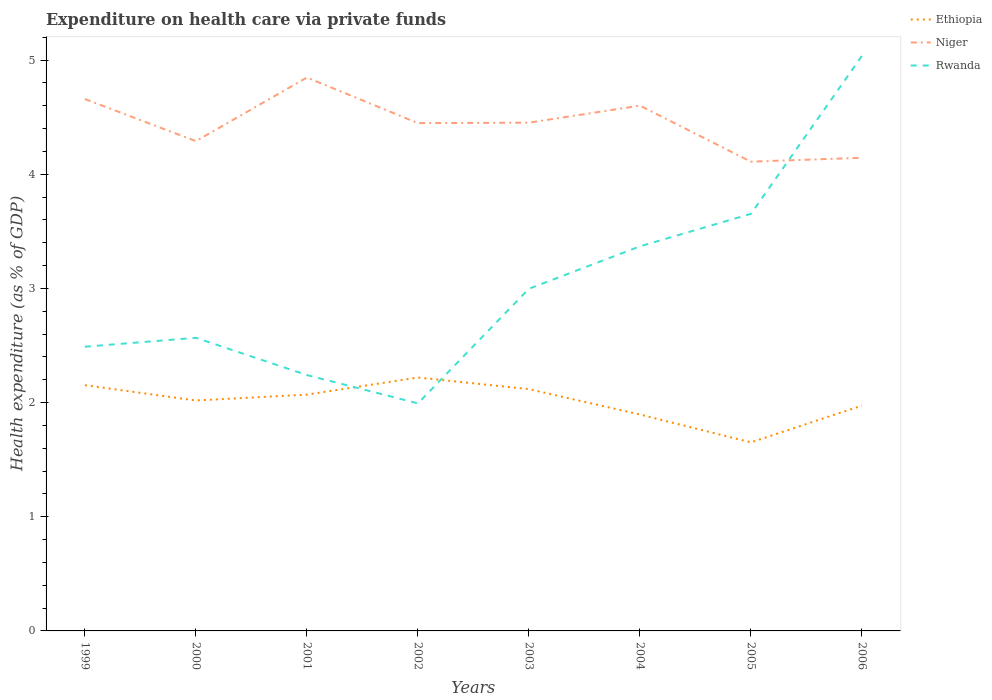Does the line corresponding to Rwanda intersect with the line corresponding to Niger?
Keep it short and to the point. Yes. Is the number of lines equal to the number of legend labels?
Your answer should be very brief. Yes. Across all years, what is the maximum expenditure made on health care in Ethiopia?
Make the answer very short. 1.65. In which year was the expenditure made on health care in Rwanda maximum?
Provide a short and direct response. 2002. What is the total expenditure made on health care in Niger in the graph?
Keep it short and to the point. 0.34. What is the difference between the highest and the second highest expenditure made on health care in Niger?
Your response must be concise. 0.74. What is the difference between the highest and the lowest expenditure made on health care in Ethiopia?
Provide a succinct answer. 5. Is the expenditure made on health care in Niger strictly greater than the expenditure made on health care in Rwanda over the years?
Keep it short and to the point. No. How many lines are there?
Keep it short and to the point. 3. What is the difference between two consecutive major ticks on the Y-axis?
Keep it short and to the point. 1. How many legend labels are there?
Offer a terse response. 3. How are the legend labels stacked?
Your answer should be compact. Vertical. What is the title of the graph?
Provide a succinct answer. Expenditure on health care via private funds. Does "Chile" appear as one of the legend labels in the graph?
Give a very brief answer. No. What is the label or title of the X-axis?
Keep it short and to the point. Years. What is the label or title of the Y-axis?
Provide a short and direct response. Health expenditure (as % of GDP). What is the Health expenditure (as % of GDP) in Ethiopia in 1999?
Make the answer very short. 2.15. What is the Health expenditure (as % of GDP) of Niger in 1999?
Give a very brief answer. 4.66. What is the Health expenditure (as % of GDP) in Rwanda in 1999?
Offer a terse response. 2.49. What is the Health expenditure (as % of GDP) of Ethiopia in 2000?
Your answer should be very brief. 2.02. What is the Health expenditure (as % of GDP) in Niger in 2000?
Provide a succinct answer. 4.29. What is the Health expenditure (as % of GDP) in Rwanda in 2000?
Give a very brief answer. 2.57. What is the Health expenditure (as % of GDP) in Ethiopia in 2001?
Give a very brief answer. 2.07. What is the Health expenditure (as % of GDP) of Niger in 2001?
Offer a very short reply. 4.85. What is the Health expenditure (as % of GDP) in Rwanda in 2001?
Offer a very short reply. 2.24. What is the Health expenditure (as % of GDP) in Ethiopia in 2002?
Ensure brevity in your answer.  2.22. What is the Health expenditure (as % of GDP) in Niger in 2002?
Make the answer very short. 4.45. What is the Health expenditure (as % of GDP) of Rwanda in 2002?
Offer a very short reply. 1.99. What is the Health expenditure (as % of GDP) of Ethiopia in 2003?
Ensure brevity in your answer.  2.12. What is the Health expenditure (as % of GDP) in Niger in 2003?
Offer a terse response. 4.45. What is the Health expenditure (as % of GDP) of Rwanda in 2003?
Provide a short and direct response. 3. What is the Health expenditure (as % of GDP) of Ethiopia in 2004?
Give a very brief answer. 1.9. What is the Health expenditure (as % of GDP) in Niger in 2004?
Keep it short and to the point. 4.6. What is the Health expenditure (as % of GDP) of Rwanda in 2004?
Give a very brief answer. 3.37. What is the Health expenditure (as % of GDP) of Ethiopia in 2005?
Give a very brief answer. 1.65. What is the Health expenditure (as % of GDP) of Niger in 2005?
Offer a terse response. 4.11. What is the Health expenditure (as % of GDP) in Rwanda in 2005?
Provide a short and direct response. 3.65. What is the Health expenditure (as % of GDP) in Ethiopia in 2006?
Your response must be concise. 1.97. What is the Health expenditure (as % of GDP) of Niger in 2006?
Your response must be concise. 4.14. What is the Health expenditure (as % of GDP) of Rwanda in 2006?
Provide a short and direct response. 5.04. Across all years, what is the maximum Health expenditure (as % of GDP) of Ethiopia?
Offer a terse response. 2.22. Across all years, what is the maximum Health expenditure (as % of GDP) in Niger?
Ensure brevity in your answer.  4.85. Across all years, what is the maximum Health expenditure (as % of GDP) of Rwanda?
Offer a terse response. 5.04. Across all years, what is the minimum Health expenditure (as % of GDP) of Ethiopia?
Make the answer very short. 1.65. Across all years, what is the minimum Health expenditure (as % of GDP) in Niger?
Provide a succinct answer. 4.11. Across all years, what is the minimum Health expenditure (as % of GDP) in Rwanda?
Your answer should be very brief. 1.99. What is the total Health expenditure (as % of GDP) in Ethiopia in the graph?
Provide a succinct answer. 16.1. What is the total Health expenditure (as % of GDP) of Niger in the graph?
Offer a terse response. 35.55. What is the total Health expenditure (as % of GDP) in Rwanda in the graph?
Offer a terse response. 24.35. What is the difference between the Health expenditure (as % of GDP) of Ethiopia in 1999 and that in 2000?
Give a very brief answer. 0.13. What is the difference between the Health expenditure (as % of GDP) in Niger in 1999 and that in 2000?
Ensure brevity in your answer.  0.37. What is the difference between the Health expenditure (as % of GDP) in Rwanda in 1999 and that in 2000?
Ensure brevity in your answer.  -0.08. What is the difference between the Health expenditure (as % of GDP) of Ethiopia in 1999 and that in 2001?
Provide a succinct answer. 0.08. What is the difference between the Health expenditure (as % of GDP) of Niger in 1999 and that in 2001?
Your answer should be very brief. -0.19. What is the difference between the Health expenditure (as % of GDP) in Rwanda in 1999 and that in 2001?
Ensure brevity in your answer.  0.25. What is the difference between the Health expenditure (as % of GDP) in Ethiopia in 1999 and that in 2002?
Ensure brevity in your answer.  -0.07. What is the difference between the Health expenditure (as % of GDP) in Niger in 1999 and that in 2002?
Ensure brevity in your answer.  0.21. What is the difference between the Health expenditure (as % of GDP) of Rwanda in 1999 and that in 2002?
Offer a very short reply. 0.5. What is the difference between the Health expenditure (as % of GDP) in Ethiopia in 1999 and that in 2003?
Your response must be concise. 0.03. What is the difference between the Health expenditure (as % of GDP) of Niger in 1999 and that in 2003?
Ensure brevity in your answer.  0.21. What is the difference between the Health expenditure (as % of GDP) in Rwanda in 1999 and that in 2003?
Your response must be concise. -0.51. What is the difference between the Health expenditure (as % of GDP) in Ethiopia in 1999 and that in 2004?
Give a very brief answer. 0.26. What is the difference between the Health expenditure (as % of GDP) of Niger in 1999 and that in 2004?
Offer a terse response. 0.06. What is the difference between the Health expenditure (as % of GDP) in Rwanda in 1999 and that in 2004?
Ensure brevity in your answer.  -0.88. What is the difference between the Health expenditure (as % of GDP) in Ethiopia in 1999 and that in 2005?
Provide a succinct answer. 0.5. What is the difference between the Health expenditure (as % of GDP) of Niger in 1999 and that in 2005?
Ensure brevity in your answer.  0.55. What is the difference between the Health expenditure (as % of GDP) of Rwanda in 1999 and that in 2005?
Your answer should be compact. -1.16. What is the difference between the Health expenditure (as % of GDP) in Ethiopia in 1999 and that in 2006?
Give a very brief answer. 0.18. What is the difference between the Health expenditure (as % of GDP) of Niger in 1999 and that in 2006?
Your response must be concise. 0.51. What is the difference between the Health expenditure (as % of GDP) in Rwanda in 1999 and that in 2006?
Make the answer very short. -2.55. What is the difference between the Health expenditure (as % of GDP) of Ethiopia in 2000 and that in 2001?
Offer a terse response. -0.05. What is the difference between the Health expenditure (as % of GDP) of Niger in 2000 and that in 2001?
Your answer should be compact. -0.56. What is the difference between the Health expenditure (as % of GDP) of Rwanda in 2000 and that in 2001?
Keep it short and to the point. 0.33. What is the difference between the Health expenditure (as % of GDP) in Ethiopia in 2000 and that in 2002?
Your response must be concise. -0.2. What is the difference between the Health expenditure (as % of GDP) of Niger in 2000 and that in 2002?
Provide a short and direct response. -0.16. What is the difference between the Health expenditure (as % of GDP) in Rwanda in 2000 and that in 2002?
Keep it short and to the point. 0.57. What is the difference between the Health expenditure (as % of GDP) of Ethiopia in 2000 and that in 2003?
Your response must be concise. -0.1. What is the difference between the Health expenditure (as % of GDP) of Niger in 2000 and that in 2003?
Make the answer very short. -0.16. What is the difference between the Health expenditure (as % of GDP) in Rwanda in 2000 and that in 2003?
Your response must be concise. -0.43. What is the difference between the Health expenditure (as % of GDP) in Ethiopia in 2000 and that in 2004?
Your answer should be compact. 0.12. What is the difference between the Health expenditure (as % of GDP) of Niger in 2000 and that in 2004?
Provide a succinct answer. -0.31. What is the difference between the Health expenditure (as % of GDP) of Rwanda in 2000 and that in 2004?
Your answer should be compact. -0.8. What is the difference between the Health expenditure (as % of GDP) of Ethiopia in 2000 and that in 2005?
Keep it short and to the point. 0.37. What is the difference between the Health expenditure (as % of GDP) in Niger in 2000 and that in 2005?
Offer a terse response. 0.18. What is the difference between the Health expenditure (as % of GDP) of Rwanda in 2000 and that in 2005?
Give a very brief answer. -1.09. What is the difference between the Health expenditure (as % of GDP) of Ethiopia in 2000 and that in 2006?
Your answer should be very brief. 0.04. What is the difference between the Health expenditure (as % of GDP) of Niger in 2000 and that in 2006?
Your answer should be compact. 0.15. What is the difference between the Health expenditure (as % of GDP) in Rwanda in 2000 and that in 2006?
Offer a very short reply. -2.47. What is the difference between the Health expenditure (as % of GDP) of Ethiopia in 2001 and that in 2002?
Provide a short and direct response. -0.15. What is the difference between the Health expenditure (as % of GDP) in Niger in 2001 and that in 2002?
Offer a terse response. 0.4. What is the difference between the Health expenditure (as % of GDP) in Rwanda in 2001 and that in 2002?
Your answer should be very brief. 0.25. What is the difference between the Health expenditure (as % of GDP) in Ethiopia in 2001 and that in 2003?
Keep it short and to the point. -0.05. What is the difference between the Health expenditure (as % of GDP) in Niger in 2001 and that in 2003?
Ensure brevity in your answer.  0.4. What is the difference between the Health expenditure (as % of GDP) of Rwanda in 2001 and that in 2003?
Offer a very short reply. -0.76. What is the difference between the Health expenditure (as % of GDP) in Ethiopia in 2001 and that in 2004?
Your answer should be very brief. 0.17. What is the difference between the Health expenditure (as % of GDP) of Niger in 2001 and that in 2004?
Your answer should be compact. 0.25. What is the difference between the Health expenditure (as % of GDP) in Rwanda in 2001 and that in 2004?
Offer a terse response. -1.13. What is the difference between the Health expenditure (as % of GDP) of Ethiopia in 2001 and that in 2005?
Your response must be concise. 0.42. What is the difference between the Health expenditure (as % of GDP) in Niger in 2001 and that in 2005?
Give a very brief answer. 0.74. What is the difference between the Health expenditure (as % of GDP) of Rwanda in 2001 and that in 2005?
Your answer should be very brief. -1.41. What is the difference between the Health expenditure (as % of GDP) in Ethiopia in 2001 and that in 2006?
Make the answer very short. 0.1. What is the difference between the Health expenditure (as % of GDP) of Niger in 2001 and that in 2006?
Ensure brevity in your answer.  0.7. What is the difference between the Health expenditure (as % of GDP) of Rwanda in 2001 and that in 2006?
Your response must be concise. -2.8. What is the difference between the Health expenditure (as % of GDP) in Ethiopia in 2002 and that in 2003?
Provide a succinct answer. 0.1. What is the difference between the Health expenditure (as % of GDP) of Niger in 2002 and that in 2003?
Your response must be concise. -0. What is the difference between the Health expenditure (as % of GDP) in Rwanda in 2002 and that in 2003?
Your answer should be compact. -1. What is the difference between the Health expenditure (as % of GDP) in Ethiopia in 2002 and that in 2004?
Your answer should be compact. 0.32. What is the difference between the Health expenditure (as % of GDP) of Niger in 2002 and that in 2004?
Ensure brevity in your answer.  -0.15. What is the difference between the Health expenditure (as % of GDP) of Rwanda in 2002 and that in 2004?
Give a very brief answer. -1.38. What is the difference between the Health expenditure (as % of GDP) in Ethiopia in 2002 and that in 2005?
Keep it short and to the point. 0.57. What is the difference between the Health expenditure (as % of GDP) in Niger in 2002 and that in 2005?
Ensure brevity in your answer.  0.34. What is the difference between the Health expenditure (as % of GDP) in Rwanda in 2002 and that in 2005?
Your answer should be very brief. -1.66. What is the difference between the Health expenditure (as % of GDP) of Ethiopia in 2002 and that in 2006?
Offer a terse response. 0.25. What is the difference between the Health expenditure (as % of GDP) of Niger in 2002 and that in 2006?
Ensure brevity in your answer.  0.3. What is the difference between the Health expenditure (as % of GDP) in Rwanda in 2002 and that in 2006?
Provide a succinct answer. -3.04. What is the difference between the Health expenditure (as % of GDP) in Ethiopia in 2003 and that in 2004?
Your answer should be compact. 0.22. What is the difference between the Health expenditure (as % of GDP) in Niger in 2003 and that in 2004?
Give a very brief answer. -0.15. What is the difference between the Health expenditure (as % of GDP) of Rwanda in 2003 and that in 2004?
Provide a short and direct response. -0.37. What is the difference between the Health expenditure (as % of GDP) in Ethiopia in 2003 and that in 2005?
Your answer should be compact. 0.47. What is the difference between the Health expenditure (as % of GDP) in Niger in 2003 and that in 2005?
Offer a very short reply. 0.34. What is the difference between the Health expenditure (as % of GDP) of Rwanda in 2003 and that in 2005?
Offer a terse response. -0.66. What is the difference between the Health expenditure (as % of GDP) in Ethiopia in 2003 and that in 2006?
Make the answer very short. 0.14. What is the difference between the Health expenditure (as % of GDP) in Niger in 2003 and that in 2006?
Your answer should be compact. 0.31. What is the difference between the Health expenditure (as % of GDP) in Rwanda in 2003 and that in 2006?
Keep it short and to the point. -2.04. What is the difference between the Health expenditure (as % of GDP) of Ethiopia in 2004 and that in 2005?
Provide a succinct answer. 0.24. What is the difference between the Health expenditure (as % of GDP) of Niger in 2004 and that in 2005?
Your response must be concise. 0.49. What is the difference between the Health expenditure (as % of GDP) of Rwanda in 2004 and that in 2005?
Give a very brief answer. -0.28. What is the difference between the Health expenditure (as % of GDP) in Ethiopia in 2004 and that in 2006?
Offer a terse response. -0.08. What is the difference between the Health expenditure (as % of GDP) of Niger in 2004 and that in 2006?
Ensure brevity in your answer.  0.46. What is the difference between the Health expenditure (as % of GDP) of Rwanda in 2004 and that in 2006?
Offer a terse response. -1.67. What is the difference between the Health expenditure (as % of GDP) of Ethiopia in 2005 and that in 2006?
Offer a very short reply. -0.32. What is the difference between the Health expenditure (as % of GDP) in Niger in 2005 and that in 2006?
Offer a terse response. -0.03. What is the difference between the Health expenditure (as % of GDP) of Rwanda in 2005 and that in 2006?
Give a very brief answer. -1.38. What is the difference between the Health expenditure (as % of GDP) in Ethiopia in 1999 and the Health expenditure (as % of GDP) in Niger in 2000?
Make the answer very short. -2.14. What is the difference between the Health expenditure (as % of GDP) in Ethiopia in 1999 and the Health expenditure (as % of GDP) in Rwanda in 2000?
Make the answer very short. -0.41. What is the difference between the Health expenditure (as % of GDP) in Niger in 1999 and the Health expenditure (as % of GDP) in Rwanda in 2000?
Offer a terse response. 2.09. What is the difference between the Health expenditure (as % of GDP) in Ethiopia in 1999 and the Health expenditure (as % of GDP) in Niger in 2001?
Give a very brief answer. -2.69. What is the difference between the Health expenditure (as % of GDP) of Ethiopia in 1999 and the Health expenditure (as % of GDP) of Rwanda in 2001?
Keep it short and to the point. -0.09. What is the difference between the Health expenditure (as % of GDP) of Niger in 1999 and the Health expenditure (as % of GDP) of Rwanda in 2001?
Give a very brief answer. 2.42. What is the difference between the Health expenditure (as % of GDP) of Ethiopia in 1999 and the Health expenditure (as % of GDP) of Niger in 2002?
Your response must be concise. -2.3. What is the difference between the Health expenditure (as % of GDP) of Ethiopia in 1999 and the Health expenditure (as % of GDP) of Rwanda in 2002?
Provide a succinct answer. 0.16. What is the difference between the Health expenditure (as % of GDP) of Niger in 1999 and the Health expenditure (as % of GDP) of Rwanda in 2002?
Offer a very short reply. 2.67. What is the difference between the Health expenditure (as % of GDP) in Ethiopia in 1999 and the Health expenditure (as % of GDP) in Niger in 2003?
Provide a succinct answer. -2.3. What is the difference between the Health expenditure (as % of GDP) of Ethiopia in 1999 and the Health expenditure (as % of GDP) of Rwanda in 2003?
Provide a short and direct response. -0.84. What is the difference between the Health expenditure (as % of GDP) of Niger in 1999 and the Health expenditure (as % of GDP) of Rwanda in 2003?
Your response must be concise. 1.66. What is the difference between the Health expenditure (as % of GDP) of Ethiopia in 1999 and the Health expenditure (as % of GDP) of Niger in 2004?
Your answer should be very brief. -2.45. What is the difference between the Health expenditure (as % of GDP) of Ethiopia in 1999 and the Health expenditure (as % of GDP) of Rwanda in 2004?
Your answer should be very brief. -1.22. What is the difference between the Health expenditure (as % of GDP) of Niger in 1999 and the Health expenditure (as % of GDP) of Rwanda in 2004?
Offer a very short reply. 1.29. What is the difference between the Health expenditure (as % of GDP) in Ethiopia in 1999 and the Health expenditure (as % of GDP) in Niger in 2005?
Offer a very short reply. -1.96. What is the difference between the Health expenditure (as % of GDP) in Ethiopia in 1999 and the Health expenditure (as % of GDP) in Rwanda in 2005?
Offer a terse response. -1.5. What is the difference between the Health expenditure (as % of GDP) in Niger in 1999 and the Health expenditure (as % of GDP) in Rwanda in 2005?
Your answer should be very brief. 1.01. What is the difference between the Health expenditure (as % of GDP) of Ethiopia in 1999 and the Health expenditure (as % of GDP) of Niger in 2006?
Provide a succinct answer. -1.99. What is the difference between the Health expenditure (as % of GDP) of Ethiopia in 1999 and the Health expenditure (as % of GDP) of Rwanda in 2006?
Keep it short and to the point. -2.88. What is the difference between the Health expenditure (as % of GDP) of Niger in 1999 and the Health expenditure (as % of GDP) of Rwanda in 2006?
Offer a very short reply. -0.38. What is the difference between the Health expenditure (as % of GDP) in Ethiopia in 2000 and the Health expenditure (as % of GDP) in Niger in 2001?
Give a very brief answer. -2.83. What is the difference between the Health expenditure (as % of GDP) in Ethiopia in 2000 and the Health expenditure (as % of GDP) in Rwanda in 2001?
Provide a short and direct response. -0.22. What is the difference between the Health expenditure (as % of GDP) of Niger in 2000 and the Health expenditure (as % of GDP) of Rwanda in 2001?
Keep it short and to the point. 2.05. What is the difference between the Health expenditure (as % of GDP) in Ethiopia in 2000 and the Health expenditure (as % of GDP) in Niger in 2002?
Offer a very short reply. -2.43. What is the difference between the Health expenditure (as % of GDP) in Ethiopia in 2000 and the Health expenditure (as % of GDP) in Rwanda in 2002?
Make the answer very short. 0.03. What is the difference between the Health expenditure (as % of GDP) of Niger in 2000 and the Health expenditure (as % of GDP) of Rwanda in 2002?
Your response must be concise. 2.3. What is the difference between the Health expenditure (as % of GDP) in Ethiopia in 2000 and the Health expenditure (as % of GDP) in Niger in 2003?
Give a very brief answer. -2.43. What is the difference between the Health expenditure (as % of GDP) of Ethiopia in 2000 and the Health expenditure (as % of GDP) of Rwanda in 2003?
Ensure brevity in your answer.  -0.98. What is the difference between the Health expenditure (as % of GDP) in Niger in 2000 and the Health expenditure (as % of GDP) in Rwanda in 2003?
Your response must be concise. 1.29. What is the difference between the Health expenditure (as % of GDP) of Ethiopia in 2000 and the Health expenditure (as % of GDP) of Niger in 2004?
Offer a very short reply. -2.58. What is the difference between the Health expenditure (as % of GDP) in Ethiopia in 2000 and the Health expenditure (as % of GDP) in Rwanda in 2004?
Provide a short and direct response. -1.35. What is the difference between the Health expenditure (as % of GDP) of Niger in 2000 and the Health expenditure (as % of GDP) of Rwanda in 2004?
Your answer should be very brief. 0.92. What is the difference between the Health expenditure (as % of GDP) of Ethiopia in 2000 and the Health expenditure (as % of GDP) of Niger in 2005?
Provide a succinct answer. -2.09. What is the difference between the Health expenditure (as % of GDP) in Ethiopia in 2000 and the Health expenditure (as % of GDP) in Rwanda in 2005?
Your answer should be compact. -1.63. What is the difference between the Health expenditure (as % of GDP) in Niger in 2000 and the Health expenditure (as % of GDP) in Rwanda in 2005?
Provide a succinct answer. 0.64. What is the difference between the Health expenditure (as % of GDP) of Ethiopia in 2000 and the Health expenditure (as % of GDP) of Niger in 2006?
Offer a terse response. -2.13. What is the difference between the Health expenditure (as % of GDP) in Ethiopia in 2000 and the Health expenditure (as % of GDP) in Rwanda in 2006?
Provide a short and direct response. -3.02. What is the difference between the Health expenditure (as % of GDP) in Niger in 2000 and the Health expenditure (as % of GDP) in Rwanda in 2006?
Offer a very short reply. -0.75. What is the difference between the Health expenditure (as % of GDP) in Ethiopia in 2001 and the Health expenditure (as % of GDP) in Niger in 2002?
Offer a terse response. -2.38. What is the difference between the Health expenditure (as % of GDP) of Ethiopia in 2001 and the Health expenditure (as % of GDP) of Rwanda in 2002?
Keep it short and to the point. 0.08. What is the difference between the Health expenditure (as % of GDP) in Niger in 2001 and the Health expenditure (as % of GDP) in Rwanda in 2002?
Your answer should be very brief. 2.85. What is the difference between the Health expenditure (as % of GDP) in Ethiopia in 2001 and the Health expenditure (as % of GDP) in Niger in 2003?
Provide a succinct answer. -2.38. What is the difference between the Health expenditure (as % of GDP) in Ethiopia in 2001 and the Health expenditure (as % of GDP) in Rwanda in 2003?
Your response must be concise. -0.93. What is the difference between the Health expenditure (as % of GDP) in Niger in 2001 and the Health expenditure (as % of GDP) in Rwanda in 2003?
Ensure brevity in your answer.  1.85. What is the difference between the Health expenditure (as % of GDP) in Ethiopia in 2001 and the Health expenditure (as % of GDP) in Niger in 2004?
Give a very brief answer. -2.53. What is the difference between the Health expenditure (as % of GDP) in Ethiopia in 2001 and the Health expenditure (as % of GDP) in Rwanda in 2004?
Provide a short and direct response. -1.3. What is the difference between the Health expenditure (as % of GDP) of Niger in 2001 and the Health expenditure (as % of GDP) of Rwanda in 2004?
Your answer should be very brief. 1.48. What is the difference between the Health expenditure (as % of GDP) of Ethiopia in 2001 and the Health expenditure (as % of GDP) of Niger in 2005?
Your answer should be very brief. -2.04. What is the difference between the Health expenditure (as % of GDP) of Ethiopia in 2001 and the Health expenditure (as % of GDP) of Rwanda in 2005?
Give a very brief answer. -1.58. What is the difference between the Health expenditure (as % of GDP) of Niger in 2001 and the Health expenditure (as % of GDP) of Rwanda in 2005?
Give a very brief answer. 1.19. What is the difference between the Health expenditure (as % of GDP) in Ethiopia in 2001 and the Health expenditure (as % of GDP) in Niger in 2006?
Provide a succinct answer. -2.07. What is the difference between the Health expenditure (as % of GDP) of Ethiopia in 2001 and the Health expenditure (as % of GDP) of Rwanda in 2006?
Offer a very short reply. -2.97. What is the difference between the Health expenditure (as % of GDP) of Niger in 2001 and the Health expenditure (as % of GDP) of Rwanda in 2006?
Offer a terse response. -0.19. What is the difference between the Health expenditure (as % of GDP) of Ethiopia in 2002 and the Health expenditure (as % of GDP) of Niger in 2003?
Keep it short and to the point. -2.23. What is the difference between the Health expenditure (as % of GDP) in Ethiopia in 2002 and the Health expenditure (as % of GDP) in Rwanda in 2003?
Your answer should be compact. -0.78. What is the difference between the Health expenditure (as % of GDP) of Niger in 2002 and the Health expenditure (as % of GDP) of Rwanda in 2003?
Offer a terse response. 1.45. What is the difference between the Health expenditure (as % of GDP) of Ethiopia in 2002 and the Health expenditure (as % of GDP) of Niger in 2004?
Ensure brevity in your answer.  -2.38. What is the difference between the Health expenditure (as % of GDP) in Ethiopia in 2002 and the Health expenditure (as % of GDP) in Rwanda in 2004?
Offer a very short reply. -1.15. What is the difference between the Health expenditure (as % of GDP) in Niger in 2002 and the Health expenditure (as % of GDP) in Rwanda in 2004?
Provide a succinct answer. 1.08. What is the difference between the Health expenditure (as % of GDP) in Ethiopia in 2002 and the Health expenditure (as % of GDP) in Niger in 2005?
Your answer should be very brief. -1.89. What is the difference between the Health expenditure (as % of GDP) in Ethiopia in 2002 and the Health expenditure (as % of GDP) in Rwanda in 2005?
Offer a very short reply. -1.43. What is the difference between the Health expenditure (as % of GDP) in Niger in 2002 and the Health expenditure (as % of GDP) in Rwanda in 2005?
Your answer should be compact. 0.79. What is the difference between the Health expenditure (as % of GDP) in Ethiopia in 2002 and the Health expenditure (as % of GDP) in Niger in 2006?
Offer a very short reply. -1.92. What is the difference between the Health expenditure (as % of GDP) in Ethiopia in 2002 and the Health expenditure (as % of GDP) in Rwanda in 2006?
Your answer should be very brief. -2.82. What is the difference between the Health expenditure (as % of GDP) of Niger in 2002 and the Health expenditure (as % of GDP) of Rwanda in 2006?
Your answer should be compact. -0.59. What is the difference between the Health expenditure (as % of GDP) of Ethiopia in 2003 and the Health expenditure (as % of GDP) of Niger in 2004?
Your answer should be compact. -2.48. What is the difference between the Health expenditure (as % of GDP) in Ethiopia in 2003 and the Health expenditure (as % of GDP) in Rwanda in 2004?
Provide a short and direct response. -1.25. What is the difference between the Health expenditure (as % of GDP) in Niger in 2003 and the Health expenditure (as % of GDP) in Rwanda in 2004?
Offer a terse response. 1.08. What is the difference between the Health expenditure (as % of GDP) in Ethiopia in 2003 and the Health expenditure (as % of GDP) in Niger in 2005?
Provide a succinct answer. -1.99. What is the difference between the Health expenditure (as % of GDP) in Ethiopia in 2003 and the Health expenditure (as % of GDP) in Rwanda in 2005?
Make the answer very short. -1.54. What is the difference between the Health expenditure (as % of GDP) in Niger in 2003 and the Health expenditure (as % of GDP) in Rwanda in 2005?
Offer a terse response. 0.8. What is the difference between the Health expenditure (as % of GDP) in Ethiopia in 2003 and the Health expenditure (as % of GDP) in Niger in 2006?
Ensure brevity in your answer.  -2.03. What is the difference between the Health expenditure (as % of GDP) of Ethiopia in 2003 and the Health expenditure (as % of GDP) of Rwanda in 2006?
Your response must be concise. -2.92. What is the difference between the Health expenditure (as % of GDP) of Niger in 2003 and the Health expenditure (as % of GDP) of Rwanda in 2006?
Your answer should be very brief. -0.58. What is the difference between the Health expenditure (as % of GDP) of Ethiopia in 2004 and the Health expenditure (as % of GDP) of Niger in 2005?
Your response must be concise. -2.21. What is the difference between the Health expenditure (as % of GDP) in Ethiopia in 2004 and the Health expenditure (as % of GDP) in Rwanda in 2005?
Ensure brevity in your answer.  -1.76. What is the difference between the Health expenditure (as % of GDP) in Niger in 2004 and the Health expenditure (as % of GDP) in Rwanda in 2005?
Provide a short and direct response. 0.95. What is the difference between the Health expenditure (as % of GDP) in Ethiopia in 2004 and the Health expenditure (as % of GDP) in Niger in 2006?
Keep it short and to the point. -2.25. What is the difference between the Health expenditure (as % of GDP) of Ethiopia in 2004 and the Health expenditure (as % of GDP) of Rwanda in 2006?
Your answer should be compact. -3.14. What is the difference between the Health expenditure (as % of GDP) of Niger in 2004 and the Health expenditure (as % of GDP) of Rwanda in 2006?
Provide a succinct answer. -0.44. What is the difference between the Health expenditure (as % of GDP) of Ethiopia in 2005 and the Health expenditure (as % of GDP) of Niger in 2006?
Offer a terse response. -2.49. What is the difference between the Health expenditure (as % of GDP) of Ethiopia in 2005 and the Health expenditure (as % of GDP) of Rwanda in 2006?
Provide a succinct answer. -3.39. What is the difference between the Health expenditure (as % of GDP) in Niger in 2005 and the Health expenditure (as % of GDP) in Rwanda in 2006?
Your answer should be very brief. -0.93. What is the average Health expenditure (as % of GDP) of Ethiopia per year?
Provide a succinct answer. 2.01. What is the average Health expenditure (as % of GDP) in Niger per year?
Your answer should be compact. 4.44. What is the average Health expenditure (as % of GDP) of Rwanda per year?
Offer a terse response. 3.04. In the year 1999, what is the difference between the Health expenditure (as % of GDP) of Ethiopia and Health expenditure (as % of GDP) of Niger?
Your answer should be very brief. -2.51. In the year 1999, what is the difference between the Health expenditure (as % of GDP) of Ethiopia and Health expenditure (as % of GDP) of Rwanda?
Your answer should be compact. -0.34. In the year 1999, what is the difference between the Health expenditure (as % of GDP) of Niger and Health expenditure (as % of GDP) of Rwanda?
Your answer should be compact. 2.17. In the year 2000, what is the difference between the Health expenditure (as % of GDP) of Ethiopia and Health expenditure (as % of GDP) of Niger?
Provide a succinct answer. -2.27. In the year 2000, what is the difference between the Health expenditure (as % of GDP) in Ethiopia and Health expenditure (as % of GDP) in Rwanda?
Your answer should be very brief. -0.55. In the year 2000, what is the difference between the Health expenditure (as % of GDP) of Niger and Health expenditure (as % of GDP) of Rwanda?
Provide a short and direct response. 1.72. In the year 2001, what is the difference between the Health expenditure (as % of GDP) in Ethiopia and Health expenditure (as % of GDP) in Niger?
Offer a terse response. -2.78. In the year 2001, what is the difference between the Health expenditure (as % of GDP) in Ethiopia and Health expenditure (as % of GDP) in Rwanda?
Ensure brevity in your answer.  -0.17. In the year 2001, what is the difference between the Health expenditure (as % of GDP) of Niger and Health expenditure (as % of GDP) of Rwanda?
Your response must be concise. 2.61. In the year 2002, what is the difference between the Health expenditure (as % of GDP) in Ethiopia and Health expenditure (as % of GDP) in Niger?
Your answer should be compact. -2.23. In the year 2002, what is the difference between the Health expenditure (as % of GDP) of Ethiopia and Health expenditure (as % of GDP) of Rwanda?
Your answer should be compact. 0.23. In the year 2002, what is the difference between the Health expenditure (as % of GDP) in Niger and Health expenditure (as % of GDP) in Rwanda?
Your answer should be very brief. 2.45. In the year 2003, what is the difference between the Health expenditure (as % of GDP) in Ethiopia and Health expenditure (as % of GDP) in Niger?
Give a very brief answer. -2.33. In the year 2003, what is the difference between the Health expenditure (as % of GDP) of Ethiopia and Health expenditure (as % of GDP) of Rwanda?
Ensure brevity in your answer.  -0.88. In the year 2003, what is the difference between the Health expenditure (as % of GDP) in Niger and Health expenditure (as % of GDP) in Rwanda?
Give a very brief answer. 1.45. In the year 2004, what is the difference between the Health expenditure (as % of GDP) in Ethiopia and Health expenditure (as % of GDP) in Niger?
Your answer should be compact. -2.71. In the year 2004, what is the difference between the Health expenditure (as % of GDP) of Ethiopia and Health expenditure (as % of GDP) of Rwanda?
Offer a very short reply. -1.47. In the year 2004, what is the difference between the Health expenditure (as % of GDP) in Niger and Health expenditure (as % of GDP) in Rwanda?
Make the answer very short. 1.23. In the year 2005, what is the difference between the Health expenditure (as % of GDP) of Ethiopia and Health expenditure (as % of GDP) of Niger?
Offer a terse response. -2.46. In the year 2005, what is the difference between the Health expenditure (as % of GDP) in Ethiopia and Health expenditure (as % of GDP) in Rwanda?
Provide a short and direct response. -2. In the year 2005, what is the difference between the Health expenditure (as % of GDP) of Niger and Health expenditure (as % of GDP) of Rwanda?
Provide a short and direct response. 0.46. In the year 2006, what is the difference between the Health expenditure (as % of GDP) of Ethiopia and Health expenditure (as % of GDP) of Niger?
Your answer should be compact. -2.17. In the year 2006, what is the difference between the Health expenditure (as % of GDP) of Ethiopia and Health expenditure (as % of GDP) of Rwanda?
Your answer should be compact. -3.06. In the year 2006, what is the difference between the Health expenditure (as % of GDP) in Niger and Health expenditure (as % of GDP) in Rwanda?
Give a very brief answer. -0.89. What is the ratio of the Health expenditure (as % of GDP) of Ethiopia in 1999 to that in 2000?
Provide a short and direct response. 1.07. What is the ratio of the Health expenditure (as % of GDP) in Niger in 1999 to that in 2000?
Your answer should be very brief. 1.09. What is the ratio of the Health expenditure (as % of GDP) of Rwanda in 1999 to that in 2000?
Provide a succinct answer. 0.97. What is the ratio of the Health expenditure (as % of GDP) in Ethiopia in 1999 to that in 2001?
Your answer should be very brief. 1.04. What is the ratio of the Health expenditure (as % of GDP) of Niger in 1999 to that in 2001?
Offer a very short reply. 0.96. What is the ratio of the Health expenditure (as % of GDP) in Rwanda in 1999 to that in 2001?
Your answer should be compact. 1.11. What is the ratio of the Health expenditure (as % of GDP) in Ethiopia in 1999 to that in 2002?
Your response must be concise. 0.97. What is the ratio of the Health expenditure (as % of GDP) in Niger in 1999 to that in 2002?
Your answer should be compact. 1.05. What is the ratio of the Health expenditure (as % of GDP) of Rwanda in 1999 to that in 2002?
Your response must be concise. 1.25. What is the ratio of the Health expenditure (as % of GDP) of Ethiopia in 1999 to that in 2003?
Provide a succinct answer. 1.02. What is the ratio of the Health expenditure (as % of GDP) of Niger in 1999 to that in 2003?
Offer a very short reply. 1.05. What is the ratio of the Health expenditure (as % of GDP) in Rwanda in 1999 to that in 2003?
Your response must be concise. 0.83. What is the ratio of the Health expenditure (as % of GDP) of Ethiopia in 1999 to that in 2004?
Provide a succinct answer. 1.14. What is the ratio of the Health expenditure (as % of GDP) of Niger in 1999 to that in 2004?
Keep it short and to the point. 1.01. What is the ratio of the Health expenditure (as % of GDP) in Rwanda in 1999 to that in 2004?
Ensure brevity in your answer.  0.74. What is the ratio of the Health expenditure (as % of GDP) of Ethiopia in 1999 to that in 2005?
Give a very brief answer. 1.3. What is the ratio of the Health expenditure (as % of GDP) of Niger in 1999 to that in 2005?
Offer a terse response. 1.13. What is the ratio of the Health expenditure (as % of GDP) of Rwanda in 1999 to that in 2005?
Provide a short and direct response. 0.68. What is the ratio of the Health expenditure (as % of GDP) in Ethiopia in 1999 to that in 2006?
Keep it short and to the point. 1.09. What is the ratio of the Health expenditure (as % of GDP) in Niger in 1999 to that in 2006?
Provide a succinct answer. 1.12. What is the ratio of the Health expenditure (as % of GDP) in Rwanda in 1999 to that in 2006?
Your answer should be compact. 0.49. What is the ratio of the Health expenditure (as % of GDP) of Ethiopia in 2000 to that in 2001?
Keep it short and to the point. 0.98. What is the ratio of the Health expenditure (as % of GDP) of Niger in 2000 to that in 2001?
Offer a very short reply. 0.89. What is the ratio of the Health expenditure (as % of GDP) in Rwanda in 2000 to that in 2001?
Offer a very short reply. 1.15. What is the ratio of the Health expenditure (as % of GDP) of Ethiopia in 2000 to that in 2002?
Give a very brief answer. 0.91. What is the ratio of the Health expenditure (as % of GDP) of Niger in 2000 to that in 2002?
Your answer should be compact. 0.96. What is the ratio of the Health expenditure (as % of GDP) in Rwanda in 2000 to that in 2002?
Ensure brevity in your answer.  1.29. What is the ratio of the Health expenditure (as % of GDP) of Ethiopia in 2000 to that in 2003?
Keep it short and to the point. 0.95. What is the ratio of the Health expenditure (as % of GDP) of Niger in 2000 to that in 2003?
Ensure brevity in your answer.  0.96. What is the ratio of the Health expenditure (as % of GDP) in Rwanda in 2000 to that in 2003?
Offer a terse response. 0.86. What is the ratio of the Health expenditure (as % of GDP) in Ethiopia in 2000 to that in 2004?
Provide a succinct answer. 1.06. What is the ratio of the Health expenditure (as % of GDP) of Niger in 2000 to that in 2004?
Your response must be concise. 0.93. What is the ratio of the Health expenditure (as % of GDP) in Rwanda in 2000 to that in 2004?
Offer a very short reply. 0.76. What is the ratio of the Health expenditure (as % of GDP) of Ethiopia in 2000 to that in 2005?
Keep it short and to the point. 1.22. What is the ratio of the Health expenditure (as % of GDP) of Niger in 2000 to that in 2005?
Make the answer very short. 1.04. What is the ratio of the Health expenditure (as % of GDP) in Rwanda in 2000 to that in 2005?
Ensure brevity in your answer.  0.7. What is the ratio of the Health expenditure (as % of GDP) of Ethiopia in 2000 to that in 2006?
Provide a short and direct response. 1.02. What is the ratio of the Health expenditure (as % of GDP) in Niger in 2000 to that in 2006?
Provide a short and direct response. 1.04. What is the ratio of the Health expenditure (as % of GDP) in Rwanda in 2000 to that in 2006?
Offer a very short reply. 0.51. What is the ratio of the Health expenditure (as % of GDP) of Ethiopia in 2001 to that in 2002?
Provide a succinct answer. 0.93. What is the ratio of the Health expenditure (as % of GDP) in Niger in 2001 to that in 2002?
Offer a terse response. 1.09. What is the ratio of the Health expenditure (as % of GDP) of Rwanda in 2001 to that in 2002?
Provide a short and direct response. 1.12. What is the ratio of the Health expenditure (as % of GDP) in Ethiopia in 2001 to that in 2003?
Your answer should be compact. 0.98. What is the ratio of the Health expenditure (as % of GDP) in Niger in 2001 to that in 2003?
Provide a succinct answer. 1.09. What is the ratio of the Health expenditure (as % of GDP) in Rwanda in 2001 to that in 2003?
Your response must be concise. 0.75. What is the ratio of the Health expenditure (as % of GDP) of Ethiopia in 2001 to that in 2004?
Make the answer very short. 1.09. What is the ratio of the Health expenditure (as % of GDP) of Niger in 2001 to that in 2004?
Your answer should be very brief. 1.05. What is the ratio of the Health expenditure (as % of GDP) of Rwanda in 2001 to that in 2004?
Offer a very short reply. 0.67. What is the ratio of the Health expenditure (as % of GDP) of Ethiopia in 2001 to that in 2005?
Your answer should be very brief. 1.25. What is the ratio of the Health expenditure (as % of GDP) in Niger in 2001 to that in 2005?
Offer a very short reply. 1.18. What is the ratio of the Health expenditure (as % of GDP) in Rwanda in 2001 to that in 2005?
Keep it short and to the point. 0.61. What is the ratio of the Health expenditure (as % of GDP) of Ethiopia in 2001 to that in 2006?
Provide a succinct answer. 1.05. What is the ratio of the Health expenditure (as % of GDP) of Niger in 2001 to that in 2006?
Your response must be concise. 1.17. What is the ratio of the Health expenditure (as % of GDP) in Rwanda in 2001 to that in 2006?
Your response must be concise. 0.44. What is the ratio of the Health expenditure (as % of GDP) in Ethiopia in 2002 to that in 2003?
Give a very brief answer. 1.05. What is the ratio of the Health expenditure (as % of GDP) in Rwanda in 2002 to that in 2003?
Keep it short and to the point. 0.67. What is the ratio of the Health expenditure (as % of GDP) of Ethiopia in 2002 to that in 2004?
Provide a short and direct response. 1.17. What is the ratio of the Health expenditure (as % of GDP) in Niger in 2002 to that in 2004?
Provide a succinct answer. 0.97. What is the ratio of the Health expenditure (as % of GDP) of Rwanda in 2002 to that in 2004?
Provide a short and direct response. 0.59. What is the ratio of the Health expenditure (as % of GDP) of Ethiopia in 2002 to that in 2005?
Offer a terse response. 1.34. What is the ratio of the Health expenditure (as % of GDP) of Niger in 2002 to that in 2005?
Provide a short and direct response. 1.08. What is the ratio of the Health expenditure (as % of GDP) in Rwanda in 2002 to that in 2005?
Give a very brief answer. 0.55. What is the ratio of the Health expenditure (as % of GDP) of Ethiopia in 2002 to that in 2006?
Give a very brief answer. 1.12. What is the ratio of the Health expenditure (as % of GDP) in Niger in 2002 to that in 2006?
Give a very brief answer. 1.07. What is the ratio of the Health expenditure (as % of GDP) in Rwanda in 2002 to that in 2006?
Ensure brevity in your answer.  0.4. What is the ratio of the Health expenditure (as % of GDP) of Ethiopia in 2003 to that in 2004?
Provide a succinct answer. 1.12. What is the ratio of the Health expenditure (as % of GDP) of Niger in 2003 to that in 2004?
Offer a terse response. 0.97. What is the ratio of the Health expenditure (as % of GDP) of Rwanda in 2003 to that in 2004?
Keep it short and to the point. 0.89. What is the ratio of the Health expenditure (as % of GDP) in Ethiopia in 2003 to that in 2005?
Provide a short and direct response. 1.28. What is the ratio of the Health expenditure (as % of GDP) of Niger in 2003 to that in 2005?
Provide a succinct answer. 1.08. What is the ratio of the Health expenditure (as % of GDP) in Rwanda in 2003 to that in 2005?
Provide a short and direct response. 0.82. What is the ratio of the Health expenditure (as % of GDP) of Ethiopia in 2003 to that in 2006?
Your response must be concise. 1.07. What is the ratio of the Health expenditure (as % of GDP) of Niger in 2003 to that in 2006?
Provide a succinct answer. 1.07. What is the ratio of the Health expenditure (as % of GDP) in Rwanda in 2003 to that in 2006?
Give a very brief answer. 0.59. What is the ratio of the Health expenditure (as % of GDP) in Ethiopia in 2004 to that in 2005?
Your answer should be very brief. 1.15. What is the ratio of the Health expenditure (as % of GDP) of Niger in 2004 to that in 2005?
Your answer should be very brief. 1.12. What is the ratio of the Health expenditure (as % of GDP) of Rwanda in 2004 to that in 2005?
Your answer should be very brief. 0.92. What is the ratio of the Health expenditure (as % of GDP) of Ethiopia in 2004 to that in 2006?
Offer a very short reply. 0.96. What is the ratio of the Health expenditure (as % of GDP) in Niger in 2004 to that in 2006?
Ensure brevity in your answer.  1.11. What is the ratio of the Health expenditure (as % of GDP) of Rwanda in 2004 to that in 2006?
Provide a succinct answer. 0.67. What is the ratio of the Health expenditure (as % of GDP) in Ethiopia in 2005 to that in 2006?
Your answer should be compact. 0.84. What is the ratio of the Health expenditure (as % of GDP) in Rwanda in 2005 to that in 2006?
Provide a short and direct response. 0.73. What is the difference between the highest and the second highest Health expenditure (as % of GDP) of Ethiopia?
Make the answer very short. 0.07. What is the difference between the highest and the second highest Health expenditure (as % of GDP) in Niger?
Your answer should be compact. 0.19. What is the difference between the highest and the second highest Health expenditure (as % of GDP) in Rwanda?
Provide a short and direct response. 1.38. What is the difference between the highest and the lowest Health expenditure (as % of GDP) of Ethiopia?
Your answer should be very brief. 0.57. What is the difference between the highest and the lowest Health expenditure (as % of GDP) of Niger?
Ensure brevity in your answer.  0.74. What is the difference between the highest and the lowest Health expenditure (as % of GDP) of Rwanda?
Provide a succinct answer. 3.04. 